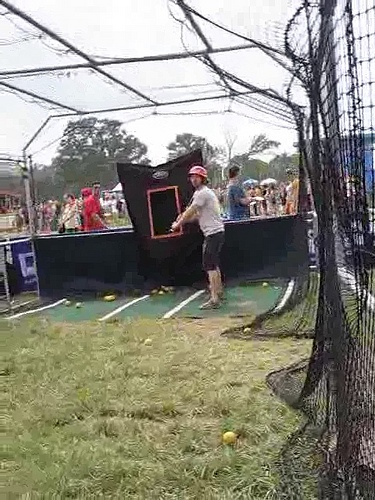Describe the objects in this image and their specific colors. I can see people in black, darkgray, and gray tones, people in black, gray, darkgray, and navy tones, people in black, brown, and maroon tones, people in black, darkgray, gray, pink, and lightgray tones, and people in black, gray, and darkgray tones in this image. 